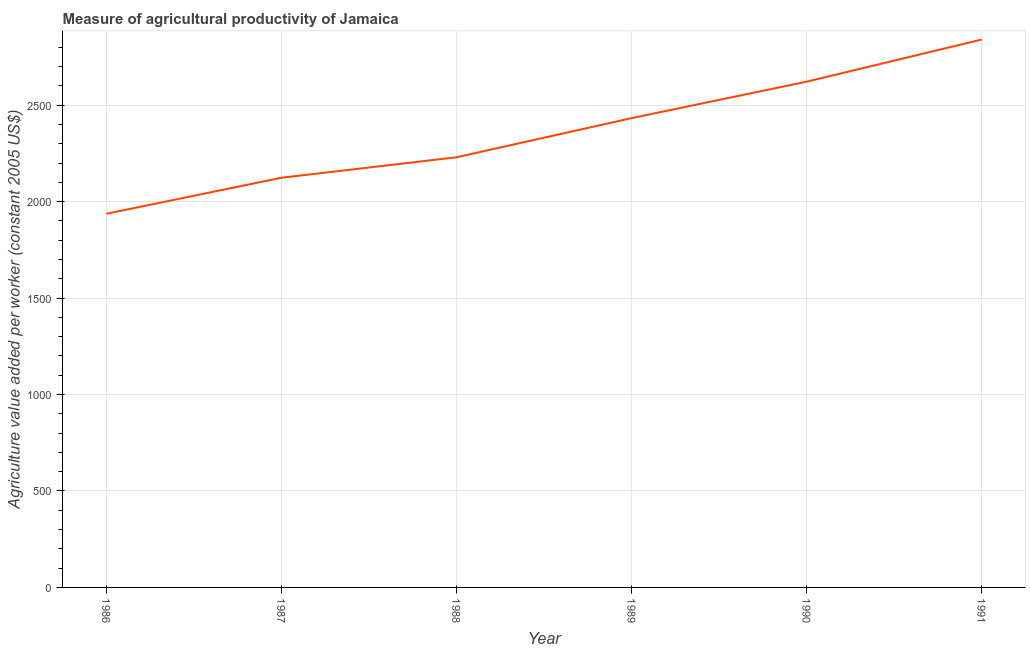What is the agriculture value added per worker in 1986?
Your answer should be compact. 1937.19. Across all years, what is the maximum agriculture value added per worker?
Offer a terse response. 2840.36. Across all years, what is the minimum agriculture value added per worker?
Your answer should be very brief. 1937.19. In which year was the agriculture value added per worker maximum?
Provide a short and direct response. 1991. In which year was the agriculture value added per worker minimum?
Give a very brief answer. 1986. What is the sum of the agriculture value added per worker?
Your answer should be compact. 1.42e+04. What is the difference between the agriculture value added per worker in 1987 and 1989?
Provide a short and direct response. -309.16. What is the average agriculture value added per worker per year?
Your response must be concise. 2364.4. What is the median agriculture value added per worker?
Your answer should be compact. 2331.53. In how many years, is the agriculture value added per worker greater than 1100 US$?
Give a very brief answer. 6. What is the ratio of the agriculture value added per worker in 1986 to that in 1990?
Provide a succinct answer. 0.74. Is the difference between the agriculture value added per worker in 1988 and 1989 greater than the difference between any two years?
Provide a succinct answer. No. What is the difference between the highest and the second highest agriculture value added per worker?
Give a very brief answer. 218.4. What is the difference between the highest and the lowest agriculture value added per worker?
Provide a short and direct response. 903.18. In how many years, is the agriculture value added per worker greater than the average agriculture value added per worker taken over all years?
Keep it short and to the point. 3. Does the agriculture value added per worker monotonically increase over the years?
Keep it short and to the point. Yes. How many lines are there?
Ensure brevity in your answer.  1. How many years are there in the graph?
Keep it short and to the point. 6. What is the difference between two consecutive major ticks on the Y-axis?
Offer a very short reply. 500. Does the graph contain any zero values?
Your response must be concise. No. What is the title of the graph?
Your answer should be compact. Measure of agricultural productivity of Jamaica. What is the label or title of the Y-axis?
Provide a succinct answer. Agriculture value added per worker (constant 2005 US$). What is the Agriculture value added per worker (constant 2005 US$) in 1986?
Provide a succinct answer. 1937.19. What is the Agriculture value added per worker (constant 2005 US$) of 1987?
Your answer should be compact. 2123.85. What is the Agriculture value added per worker (constant 2005 US$) of 1988?
Ensure brevity in your answer.  2230.06. What is the Agriculture value added per worker (constant 2005 US$) in 1989?
Your answer should be very brief. 2433. What is the Agriculture value added per worker (constant 2005 US$) in 1990?
Keep it short and to the point. 2621.96. What is the Agriculture value added per worker (constant 2005 US$) in 1991?
Your answer should be compact. 2840.36. What is the difference between the Agriculture value added per worker (constant 2005 US$) in 1986 and 1987?
Make the answer very short. -186.66. What is the difference between the Agriculture value added per worker (constant 2005 US$) in 1986 and 1988?
Make the answer very short. -292.87. What is the difference between the Agriculture value added per worker (constant 2005 US$) in 1986 and 1989?
Your response must be concise. -495.81. What is the difference between the Agriculture value added per worker (constant 2005 US$) in 1986 and 1990?
Give a very brief answer. -684.77. What is the difference between the Agriculture value added per worker (constant 2005 US$) in 1986 and 1991?
Offer a very short reply. -903.18. What is the difference between the Agriculture value added per worker (constant 2005 US$) in 1987 and 1988?
Your response must be concise. -106.21. What is the difference between the Agriculture value added per worker (constant 2005 US$) in 1987 and 1989?
Make the answer very short. -309.16. What is the difference between the Agriculture value added per worker (constant 2005 US$) in 1987 and 1990?
Provide a succinct answer. -498.12. What is the difference between the Agriculture value added per worker (constant 2005 US$) in 1987 and 1991?
Your answer should be compact. -716.52. What is the difference between the Agriculture value added per worker (constant 2005 US$) in 1988 and 1989?
Make the answer very short. -202.94. What is the difference between the Agriculture value added per worker (constant 2005 US$) in 1988 and 1990?
Give a very brief answer. -391.9. What is the difference between the Agriculture value added per worker (constant 2005 US$) in 1988 and 1991?
Provide a succinct answer. -610.3. What is the difference between the Agriculture value added per worker (constant 2005 US$) in 1989 and 1990?
Offer a very short reply. -188.96. What is the difference between the Agriculture value added per worker (constant 2005 US$) in 1989 and 1991?
Your response must be concise. -407.36. What is the difference between the Agriculture value added per worker (constant 2005 US$) in 1990 and 1991?
Ensure brevity in your answer.  -218.4. What is the ratio of the Agriculture value added per worker (constant 2005 US$) in 1986 to that in 1987?
Provide a short and direct response. 0.91. What is the ratio of the Agriculture value added per worker (constant 2005 US$) in 1986 to that in 1988?
Your response must be concise. 0.87. What is the ratio of the Agriculture value added per worker (constant 2005 US$) in 1986 to that in 1989?
Your response must be concise. 0.8. What is the ratio of the Agriculture value added per worker (constant 2005 US$) in 1986 to that in 1990?
Make the answer very short. 0.74. What is the ratio of the Agriculture value added per worker (constant 2005 US$) in 1986 to that in 1991?
Offer a terse response. 0.68. What is the ratio of the Agriculture value added per worker (constant 2005 US$) in 1987 to that in 1989?
Your response must be concise. 0.87. What is the ratio of the Agriculture value added per worker (constant 2005 US$) in 1987 to that in 1990?
Give a very brief answer. 0.81. What is the ratio of the Agriculture value added per worker (constant 2005 US$) in 1987 to that in 1991?
Offer a terse response. 0.75. What is the ratio of the Agriculture value added per worker (constant 2005 US$) in 1988 to that in 1989?
Provide a succinct answer. 0.92. What is the ratio of the Agriculture value added per worker (constant 2005 US$) in 1988 to that in 1990?
Give a very brief answer. 0.85. What is the ratio of the Agriculture value added per worker (constant 2005 US$) in 1988 to that in 1991?
Provide a succinct answer. 0.79. What is the ratio of the Agriculture value added per worker (constant 2005 US$) in 1989 to that in 1990?
Provide a short and direct response. 0.93. What is the ratio of the Agriculture value added per worker (constant 2005 US$) in 1989 to that in 1991?
Give a very brief answer. 0.86. What is the ratio of the Agriculture value added per worker (constant 2005 US$) in 1990 to that in 1991?
Your response must be concise. 0.92. 